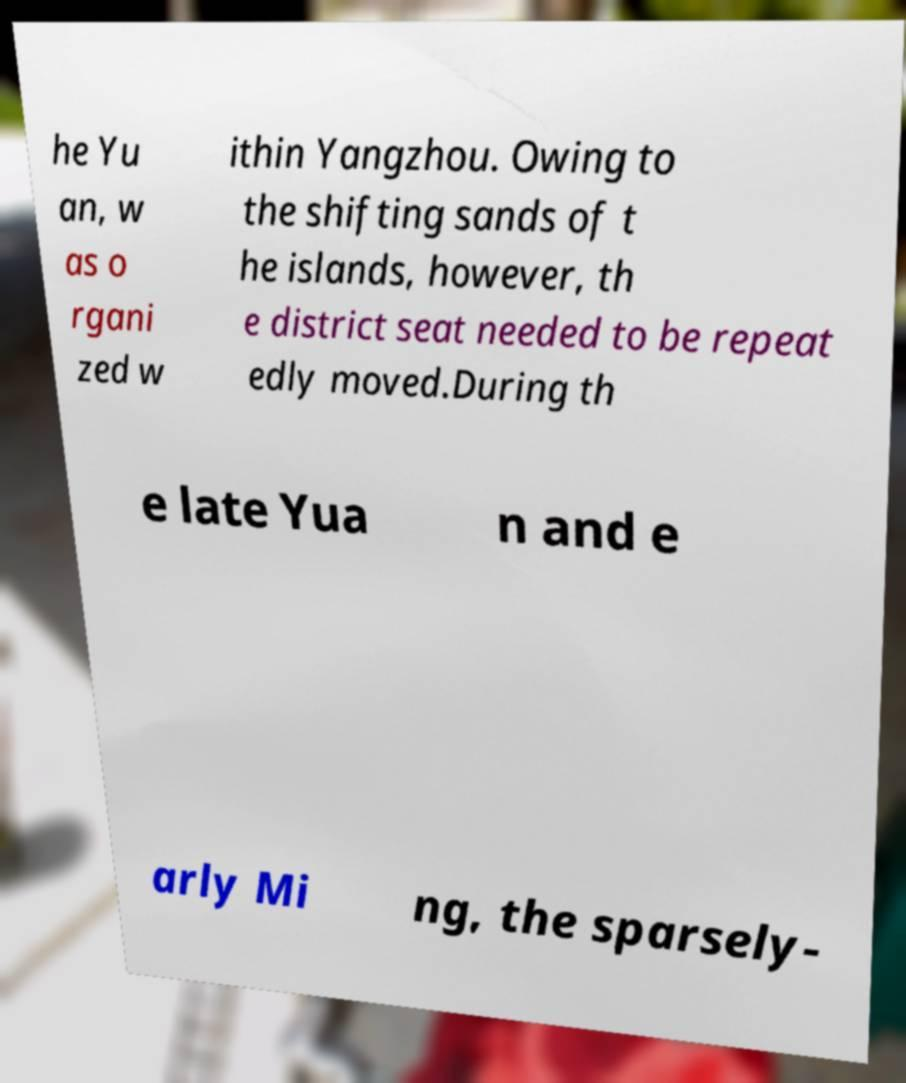What messages or text are displayed in this image? I need them in a readable, typed format. he Yu an, w as o rgani zed w ithin Yangzhou. Owing to the shifting sands of t he islands, however, th e district seat needed to be repeat edly moved.During th e late Yua n and e arly Mi ng, the sparsely- 